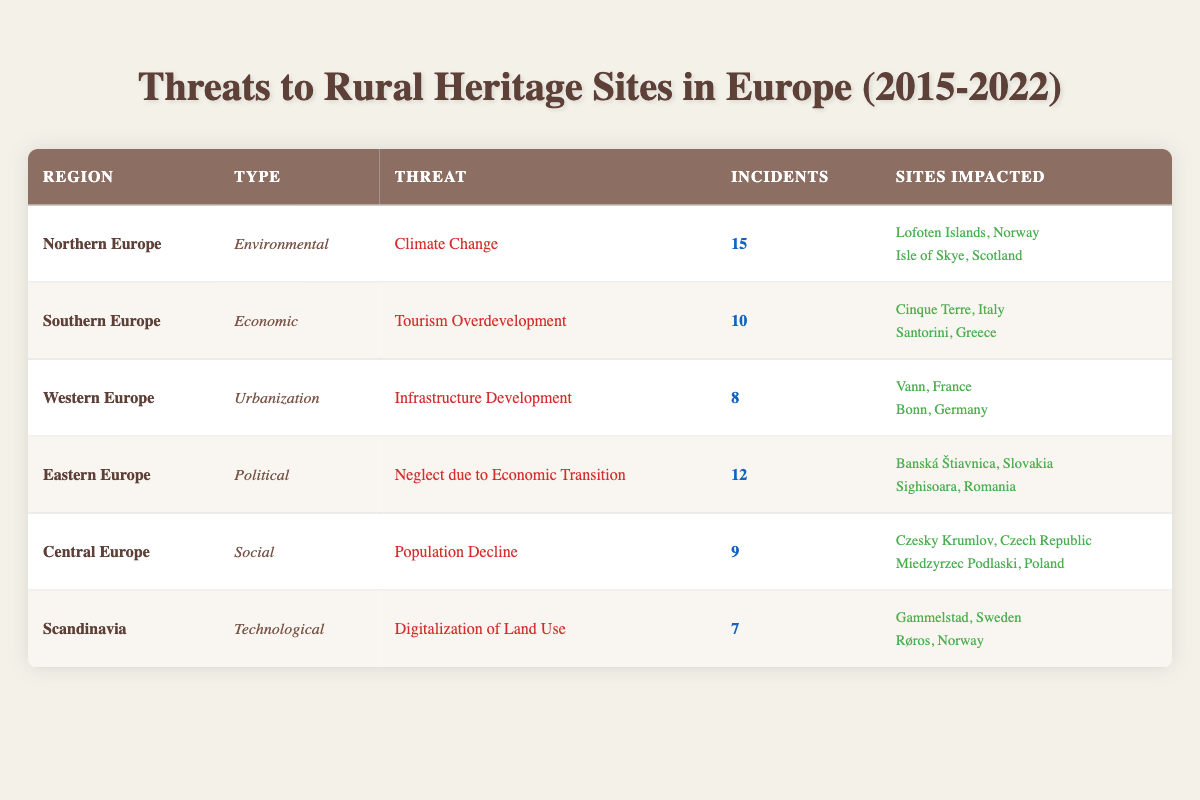What is the most common threat type listed in the table? To determine the most common threat type, we need to count the occurrences of each type in the "Type" column. The types presented in the table are Environmental (1), Economic (1), Urbanization (1), Political (1), Social (1), and Technological (1). Each type appears only once, meaning there is no single most common type.
Answer: None Which region is impacted by the highest number of incidents? To find the region with the highest number of incidents, we compare the "Incidents" column. Northern Europe has 15, Eastern Europe has 12, Southern Europe has 10, Central Europe has 9, Western Europe has 8, and Scandinavia has 7. The highest is 15 incidents in Northern Europe.
Answer: Northern Europe Are there more threats related to economic issues than any other types? We compare the number of incidents for each type. Economic threats total 10 (Southern Europe), while other types have: Environmental (15), Urbanization (8), Political (12), Social (9), and Technological (7). Since 10 is less than the highest number (15), there are not more economic threats than environmental threats.
Answer: No Which two sites in Northern Europe are affected by climate change? From the table, under Northern Europe and the threat of Climate Change, the impacted sites are listed as Lofoten Islands, Norway, and Isle of Skye, Scotland.
Answer: Lofoten Islands, Norway and Isle of Skye, Scotland What is the total number of incidents reported in Southern and Central Europe combined? First, we find the number of incidents in Southern Europe (10) and Central Europe (9). Adding these together gives 10 + 9 = 19 incidents reported in total for these two regions.
Answer: 19 Is there any threat related to technological issues, and if so, what is it? Looking at the table, we see that the "Technological" type is present in Scandinavia with a threat listed as "Digitalization of Land Use." Therefore, yes, there is a technological threat.
Answer: Yes, Digitalization of Land Use What is the difference in the number of incidents between Eastern Europe and Western Europe? For Eastern Europe, there are 12 incidents, while Western Europe has 8 incidents. To find the difference, we subtract: 12 - 8 = 4. Thus, there are 4 more incidents in Eastern Europe than in Western Europe.
Answer: 4 In which region does population decline pose a threat, according to the table? The table indicates that population decline poses a threat in Central Europe, where it is categorized as a social threat.
Answer: Central Europe 